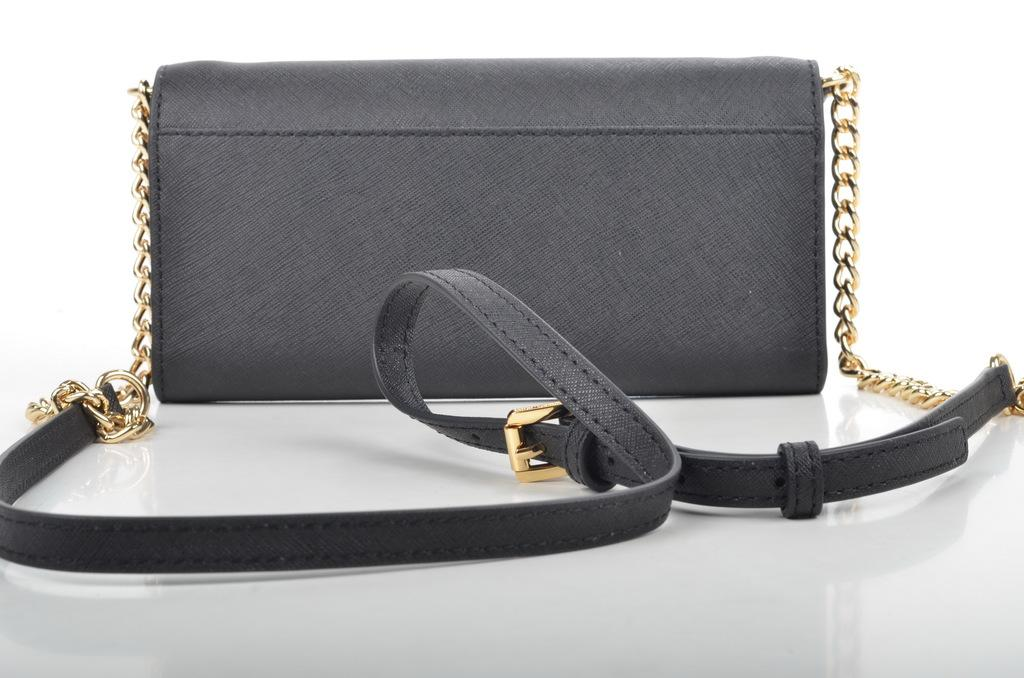What object is in the image that belongs to a woman? There is a handbag in the image that belongs to a woman. Where is the handbag located in the image? The handbag is placed on a table in the image. What is the color of the handbag? The handbag is grey in color. What can be seen in the background of the image? The background of the image is white. How many times does the woman kick the knife in the image? There is no knife or kicking action present in the image. 